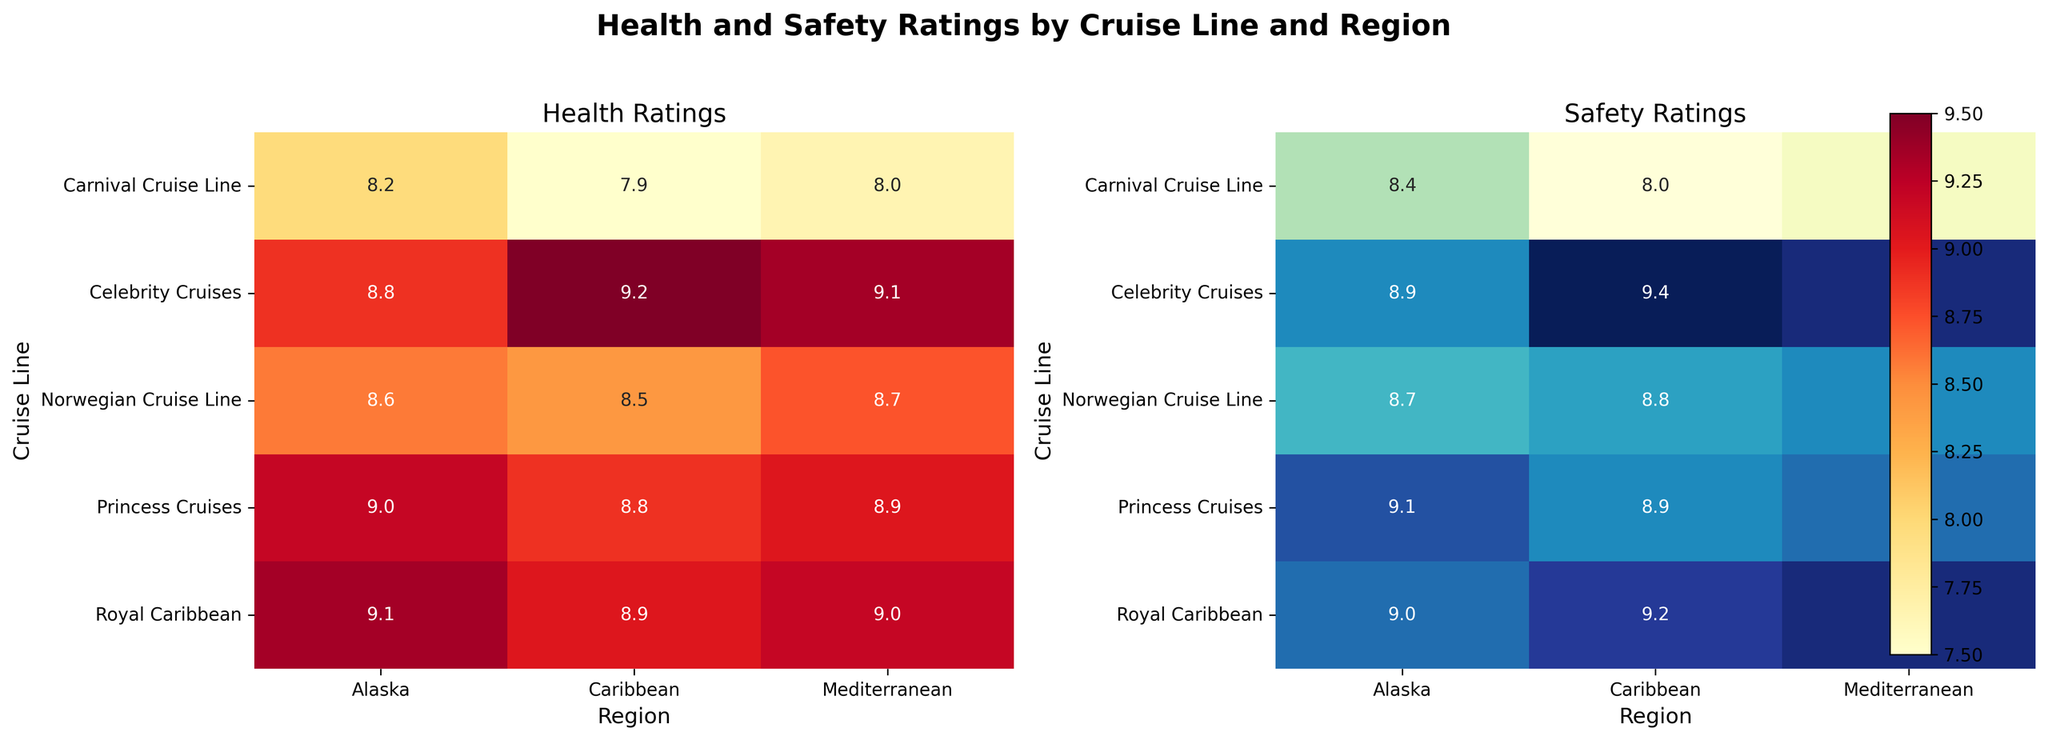What's the title of the figure? The title is located at the top of the figure, typically in a bold and larger font size. It summarizes the main topic of the plot.
Answer: Health and Safety Ratings by Cruise Line and Region How many cruise lines are represented in the figure? Count the number of unique labels along the y-axis of the heatmap, which represents the cruise lines.
Answer: Five Which cruise line has the highest health rating in the Caribbean region? In the Health Ratings heatmap, locate the Caribbean column and identify the cruise line with the highest value.
Answer: Celebrity Cruises What is the difference between the health rating and the safety rating for Princess Cruises in Alaska? Locate the corresponding cell in both heatmaps for Princess Cruises in Alaska and subtract the health rating value from the safety rating value.
Answer: 0.1 Which region does Norwegian Cruise Line have the lowest safety rating in? In the Safety Ratings heatmap, look at the rows for Norwegian Cruise Line and find the minimum value across different regions.
Answer: Alaska Compare the health ratings of Royal Caribbean in the Caribbean and Mediterranean. Which is higher, and by how much? Locate the values for Royal Caribbean in both the Caribbean and Mediterranean columns in the Health Ratings heatmap, then subtract the lower value from the higher one.
Answer: Mediterranean by 0.1 For Celebrity Cruises, what is the average of the health ratings across all three regions? Add up the health ratings for Celebrity Cruises in all three regions and then divide by the number of regions (3).
Answer: 9.03 Which cruise line has the smallest range between its highest and lowest safety ratings across all regions? For each cruise line, find the difference between its highest and lowest safety ratings across all regions. Identify the cruise line with the smallest range.
Answer: Princess Cruises with a range of 0.2 